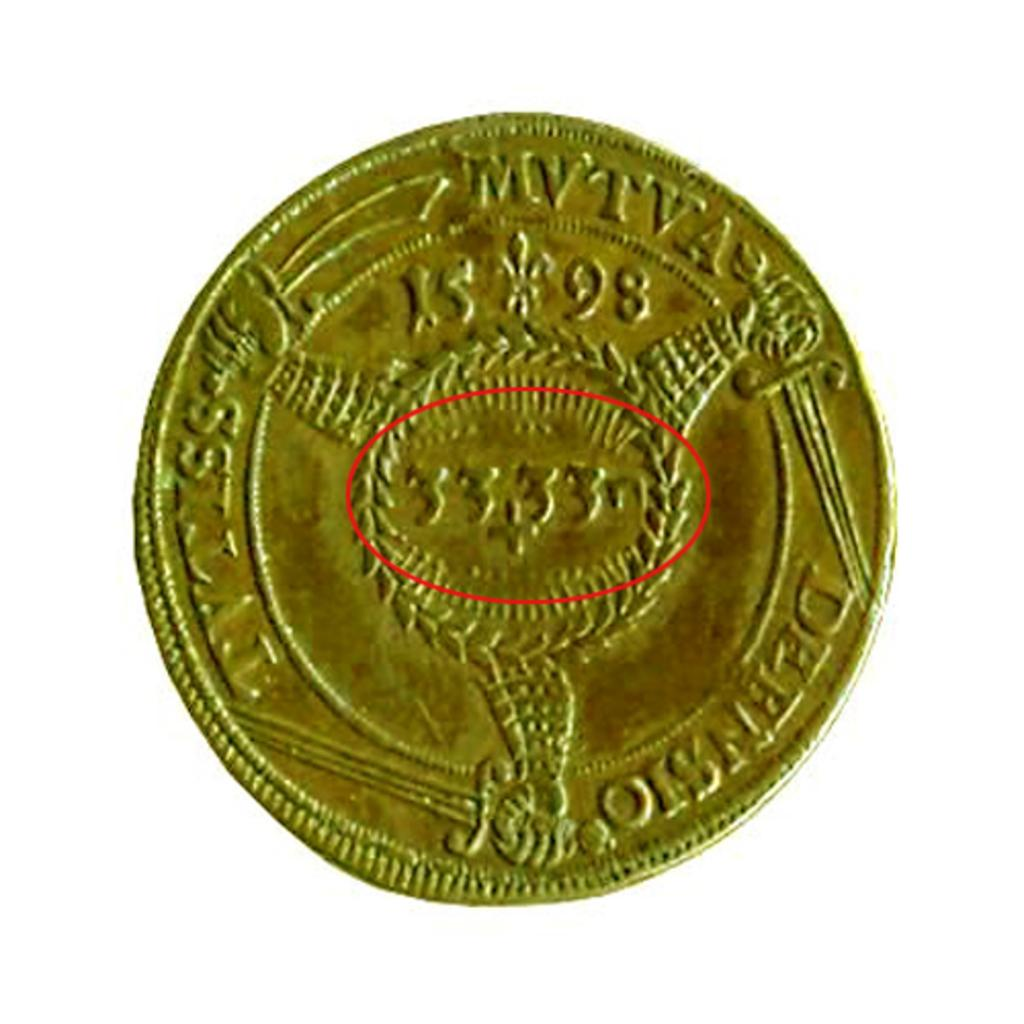<image>
Render a clear and concise summary of the photo. 33+33n is written on a gold coin below the year 1598 